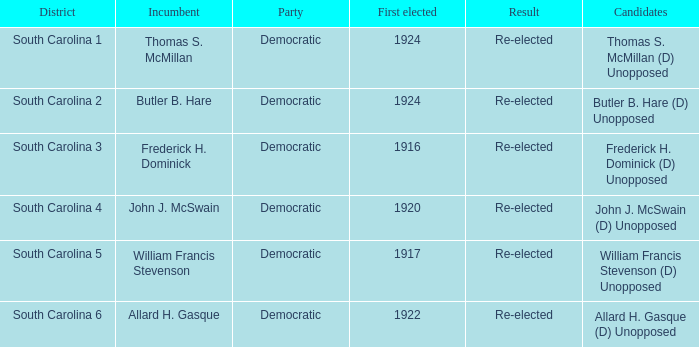What is the end product for thomas s. mcmillan? Re-elected. 